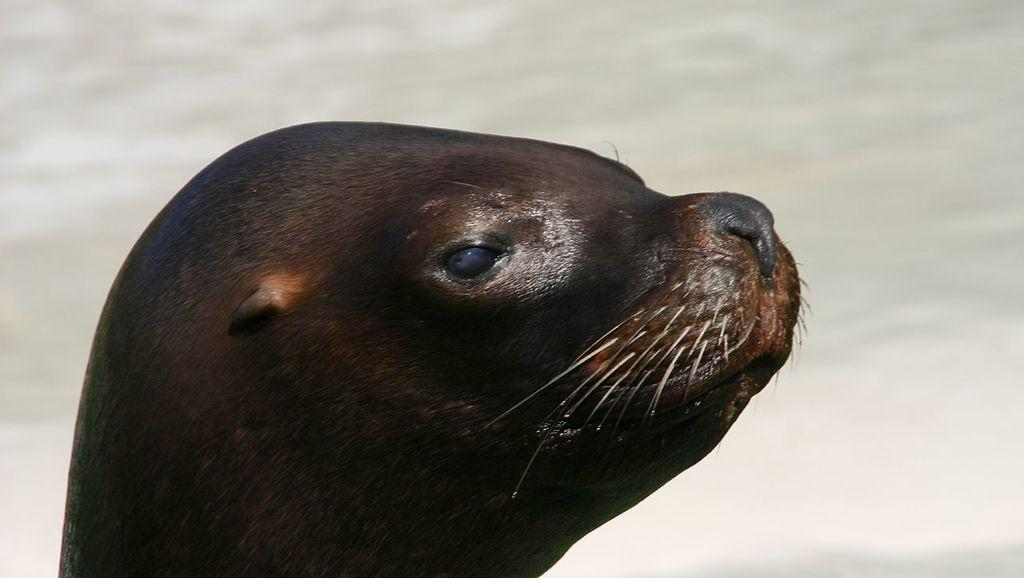What animal is present in the image? There is a seal in the image. What is the color of the seal? The seal is brown in color. What can be seen in the background of the image? There is water visible in the background of the image. Where is the cobweb located in the image? There is no cobweb present in the image. What type of furniture is visible in the image? There is no furniture visible in the image; it features a seal in a watery environment. 